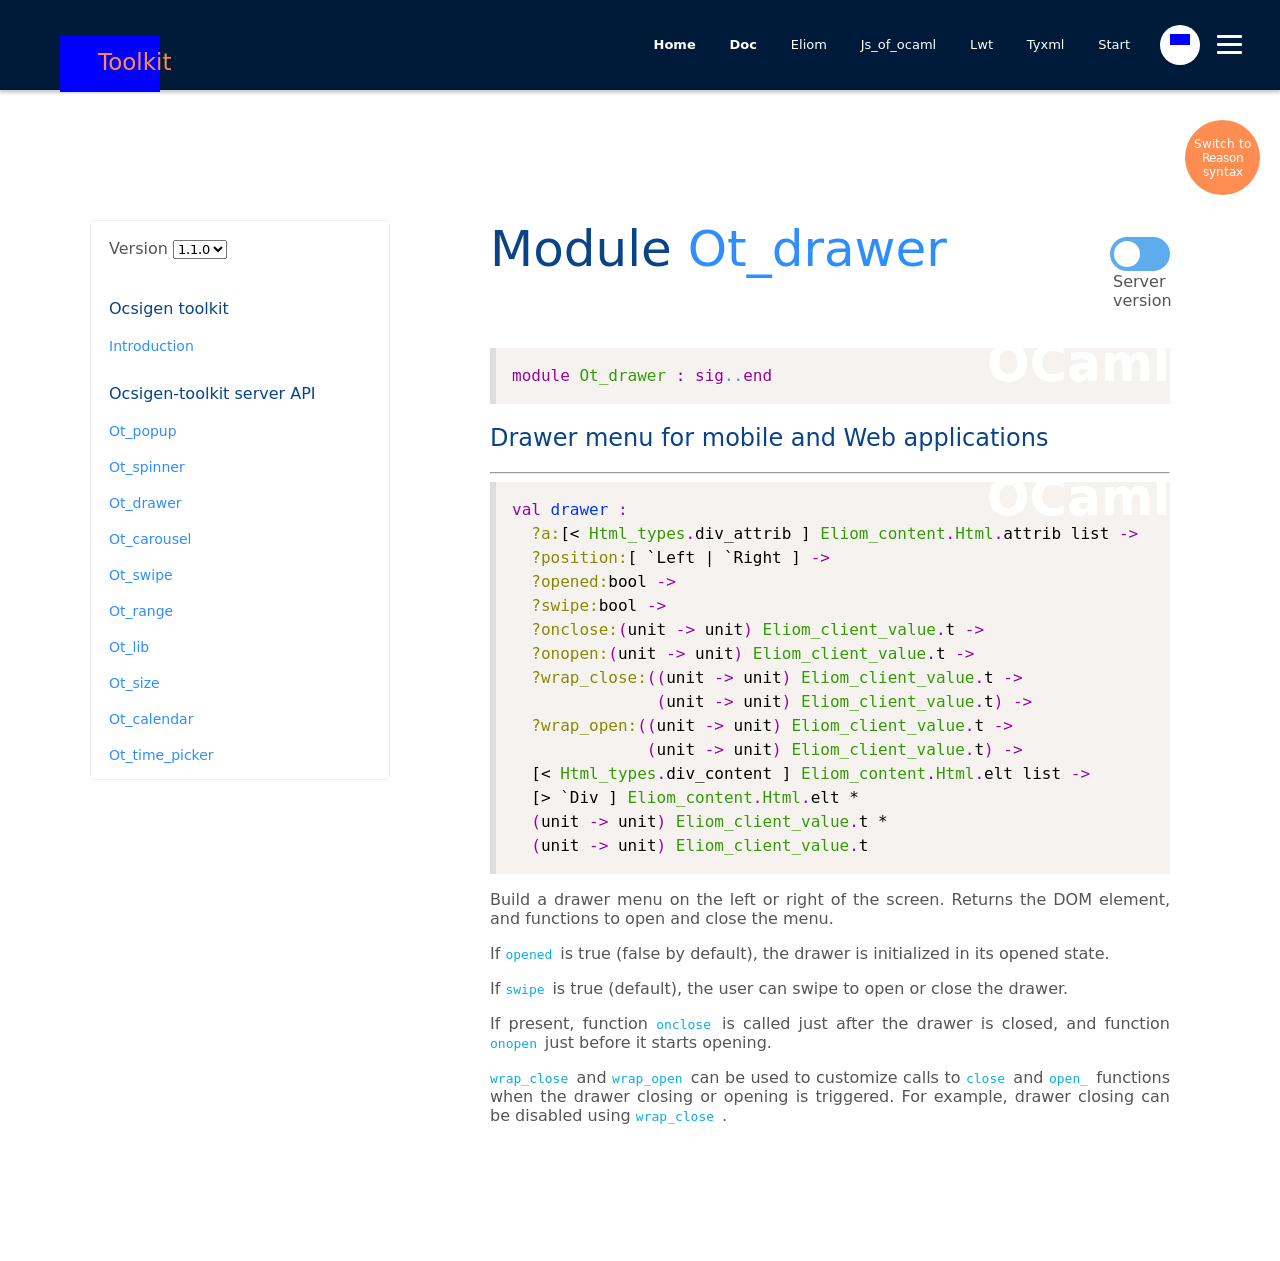What are the key components shown in this interface related to the 'Module Ot_drawer'? The key components shown in the 'Module Ot_drawer' interface include version selection, an introduction, links to various toolkit components such as Ot_popup, Ot_spinner, Ot_carousel, and more. The interface allows browsing different versions and features detailed API documentation sections for server and client implementations. 